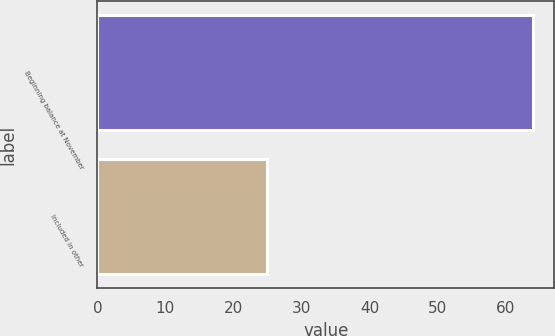Convert chart to OTSL. <chart><loc_0><loc_0><loc_500><loc_500><bar_chart><fcel>Beginning balance at November<fcel>Included in other<nl><fcel>64<fcel>25<nl></chart> 